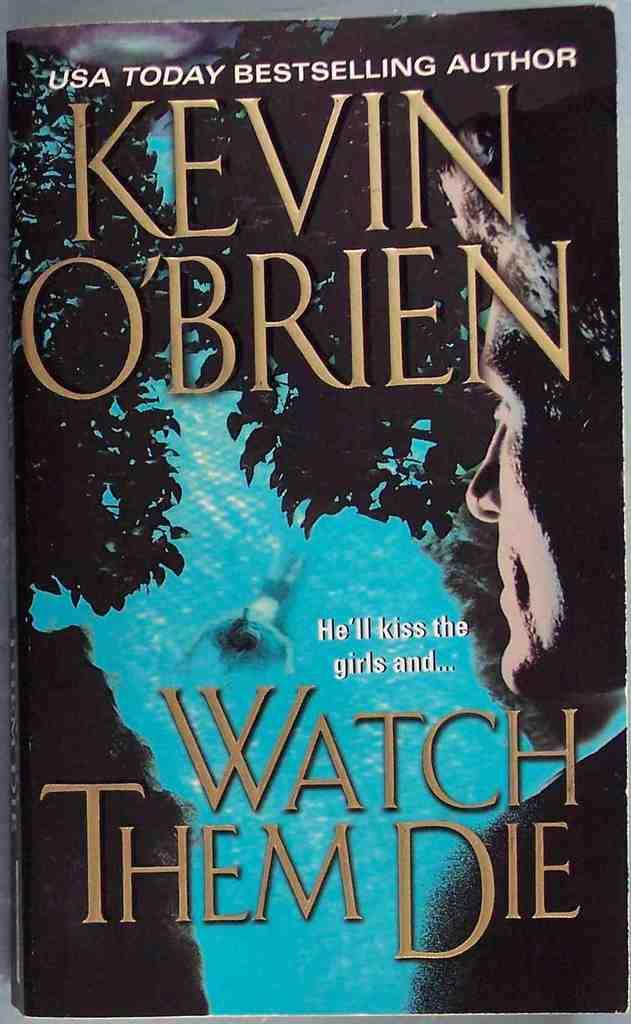<image>
Share a concise interpretation of the image provided. USA Today Bestselling Author Kevin O'Brien's book Watch Them Die. 